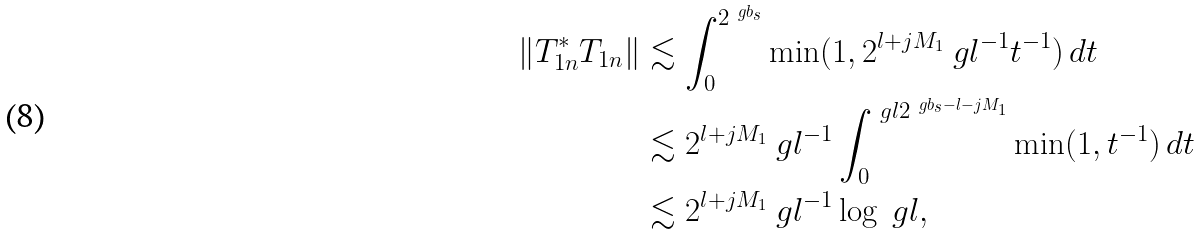<formula> <loc_0><loc_0><loc_500><loc_500>\| T _ { 1 n } ^ { * } T _ { 1 n } \| & \lesssim \int _ { 0 } ^ { 2 ^ { \ g b _ { s } } } \min ( 1 , 2 ^ { l + j M _ { 1 } } \ g l ^ { - 1 } t ^ { - 1 } ) \, d t \\ & \lesssim 2 ^ { l + j M _ { 1 } } \ g l ^ { - 1 } \int _ { 0 } ^ { \ g l 2 ^ { \ g b _ { s } - l - j M _ { 1 } } } \min ( 1 , t ^ { - 1 } ) \, d t \\ & \lesssim 2 ^ { l + j M _ { 1 } } \ g l ^ { - 1 } \log \ g l ,</formula> 